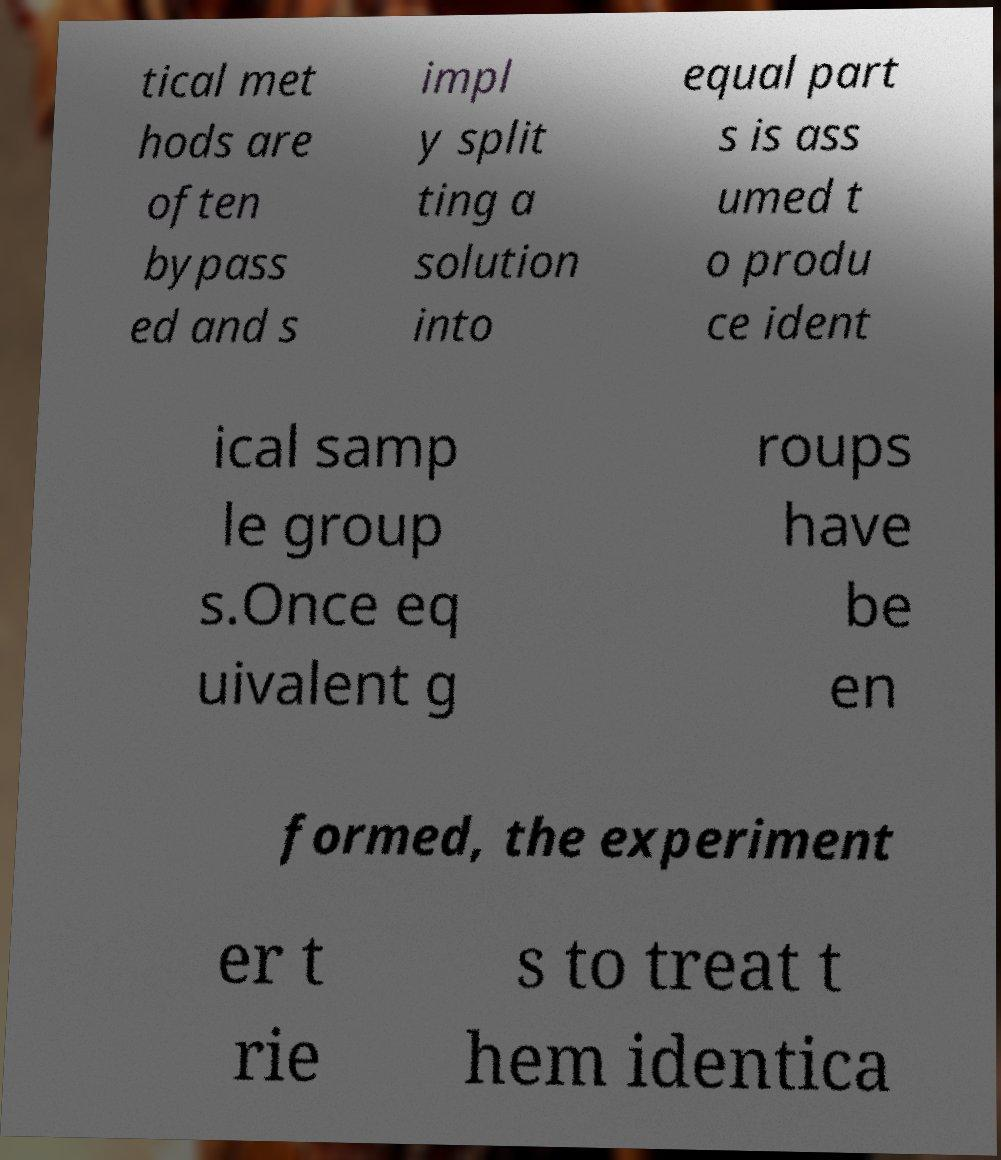Can you read and provide the text displayed in the image?This photo seems to have some interesting text. Can you extract and type it out for me? tical met hods are often bypass ed and s impl y split ting a solution into equal part s is ass umed t o produ ce ident ical samp le group s.Once eq uivalent g roups have be en formed, the experiment er t rie s to treat t hem identica 